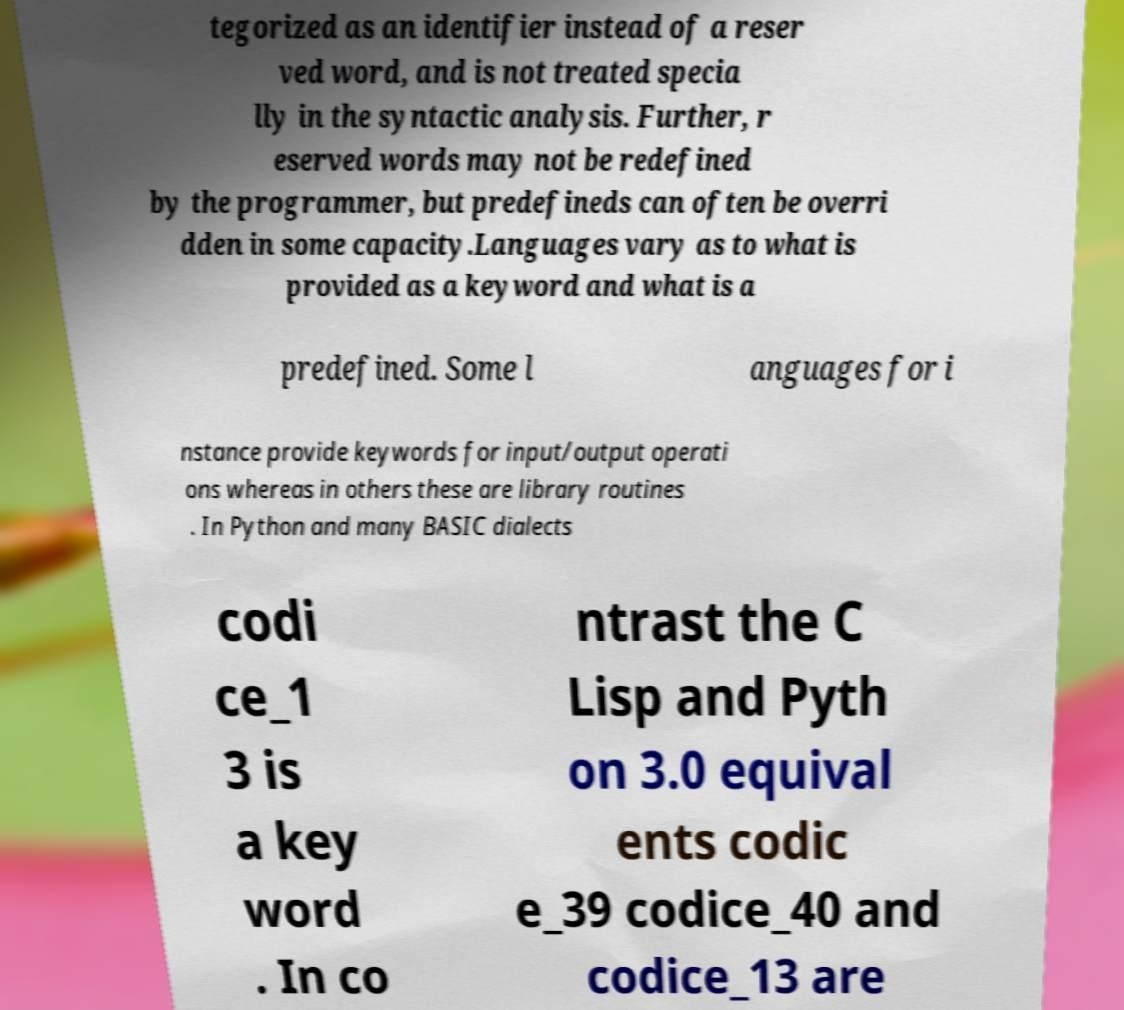There's text embedded in this image that I need extracted. Can you transcribe it verbatim? tegorized as an identifier instead of a reser ved word, and is not treated specia lly in the syntactic analysis. Further, r eserved words may not be redefined by the programmer, but predefineds can often be overri dden in some capacity.Languages vary as to what is provided as a keyword and what is a predefined. Some l anguages for i nstance provide keywords for input/output operati ons whereas in others these are library routines . In Python and many BASIC dialects codi ce_1 3 is a key word . In co ntrast the C Lisp and Pyth on 3.0 equival ents codic e_39 codice_40 and codice_13 are 